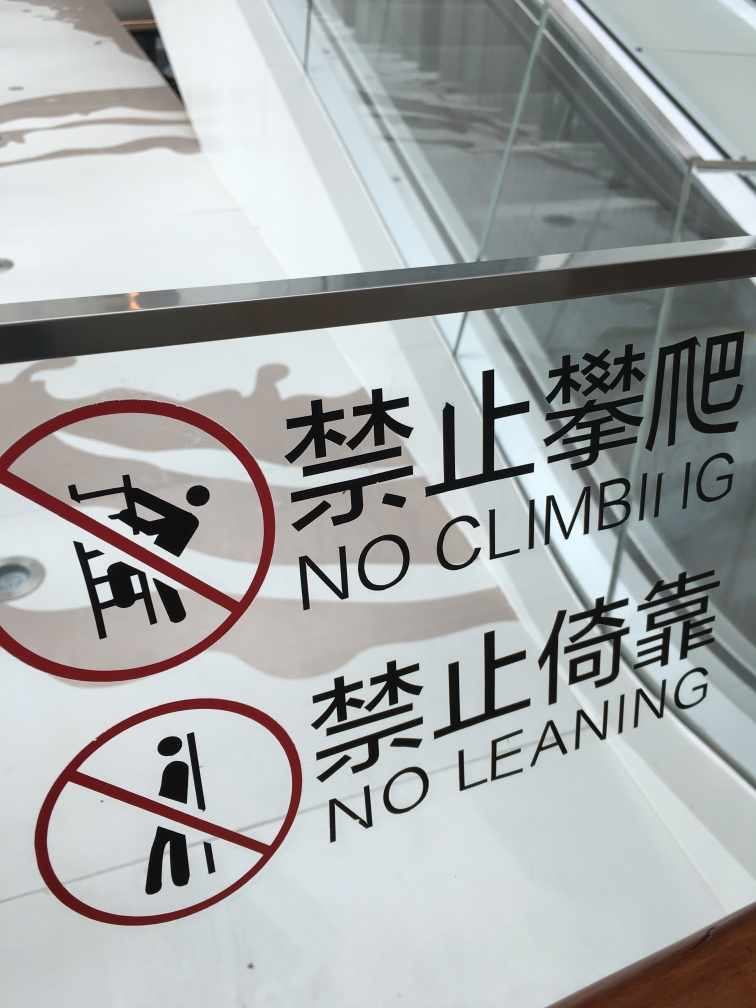Considering the design choices, how does the use of red color on the sign affect its visibility and purpose? The use of red in the safety signs enhances their visibility and draws immediate attention, which is crucial for conveying important safety warnings effectively. Red typically signifies alertness and caution, making it an apt choice for such messages. 